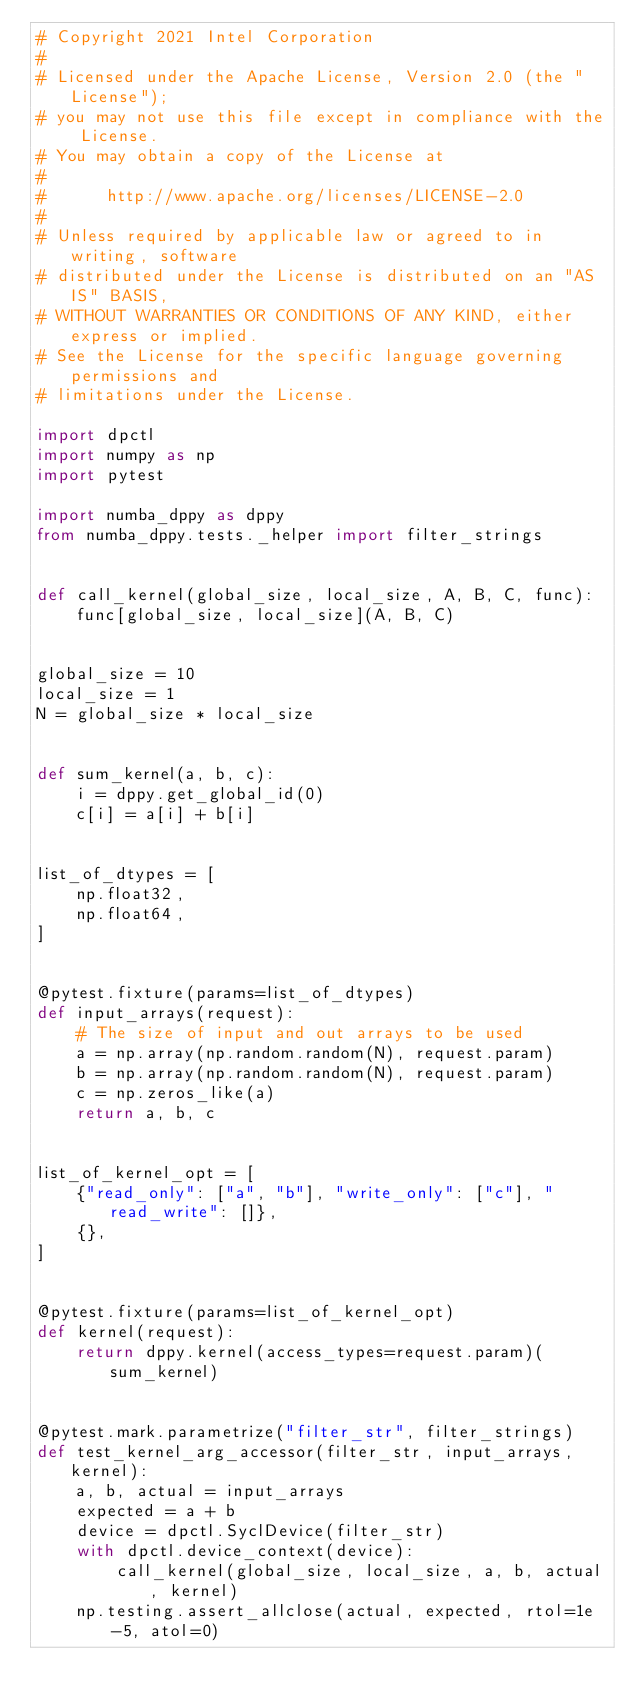<code> <loc_0><loc_0><loc_500><loc_500><_Python_># Copyright 2021 Intel Corporation
#
# Licensed under the Apache License, Version 2.0 (the "License");
# you may not use this file except in compliance with the License.
# You may obtain a copy of the License at
#
#      http://www.apache.org/licenses/LICENSE-2.0
#
# Unless required by applicable law or agreed to in writing, software
# distributed under the License is distributed on an "AS IS" BASIS,
# WITHOUT WARRANTIES OR CONDITIONS OF ANY KIND, either express or implied.
# See the License for the specific language governing permissions and
# limitations under the License.

import dpctl
import numpy as np
import pytest

import numba_dppy as dppy
from numba_dppy.tests._helper import filter_strings


def call_kernel(global_size, local_size, A, B, C, func):
    func[global_size, local_size](A, B, C)


global_size = 10
local_size = 1
N = global_size * local_size


def sum_kernel(a, b, c):
    i = dppy.get_global_id(0)
    c[i] = a[i] + b[i]


list_of_dtypes = [
    np.float32,
    np.float64,
]


@pytest.fixture(params=list_of_dtypes)
def input_arrays(request):
    # The size of input and out arrays to be used
    a = np.array(np.random.random(N), request.param)
    b = np.array(np.random.random(N), request.param)
    c = np.zeros_like(a)
    return a, b, c


list_of_kernel_opt = [
    {"read_only": ["a", "b"], "write_only": ["c"], "read_write": []},
    {},
]


@pytest.fixture(params=list_of_kernel_opt)
def kernel(request):
    return dppy.kernel(access_types=request.param)(sum_kernel)


@pytest.mark.parametrize("filter_str", filter_strings)
def test_kernel_arg_accessor(filter_str, input_arrays, kernel):
    a, b, actual = input_arrays
    expected = a + b
    device = dpctl.SyclDevice(filter_str)
    with dpctl.device_context(device):
        call_kernel(global_size, local_size, a, b, actual, kernel)
    np.testing.assert_allclose(actual, expected, rtol=1e-5, atol=0)
</code> 